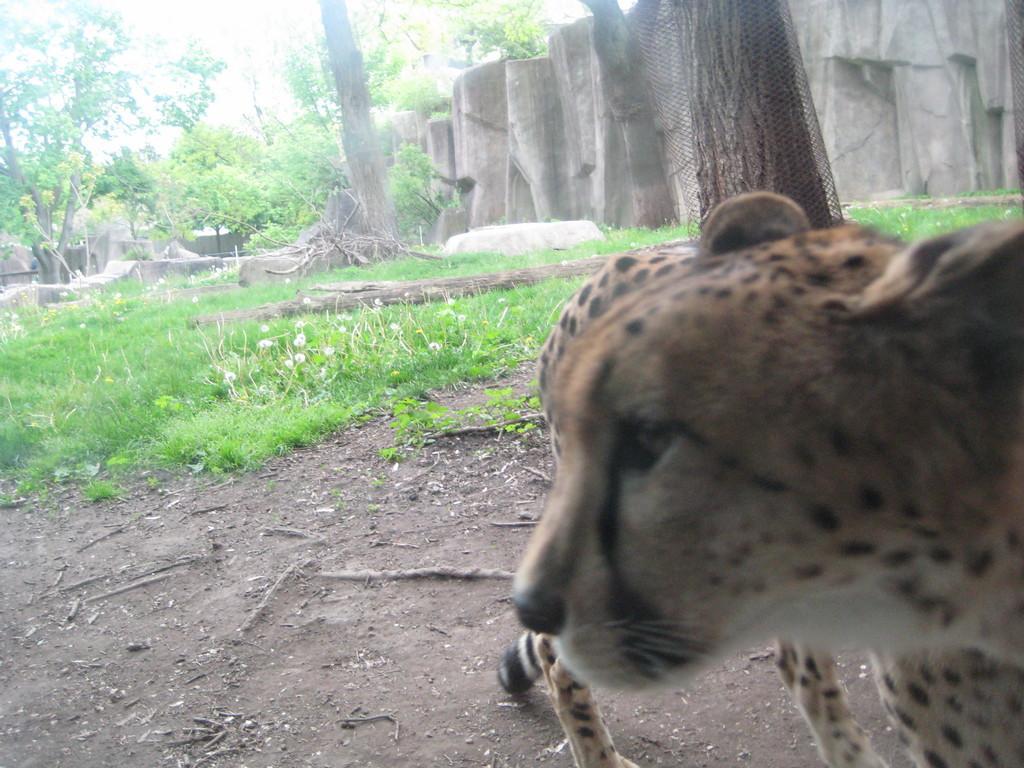Can you describe this image briefly? In this image I can see a cheetah which is brown, black and cream in color is standing on the ground. I can see some grass on the ground, few trees, few white colored flowers, the wall and the sky in the background. 